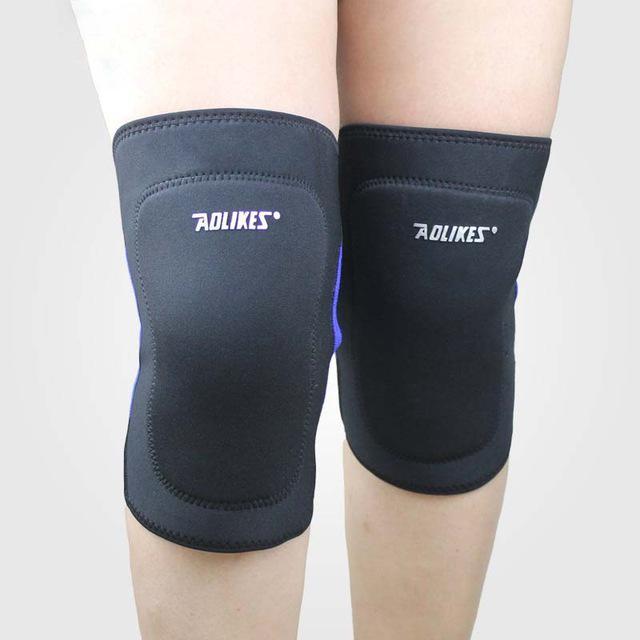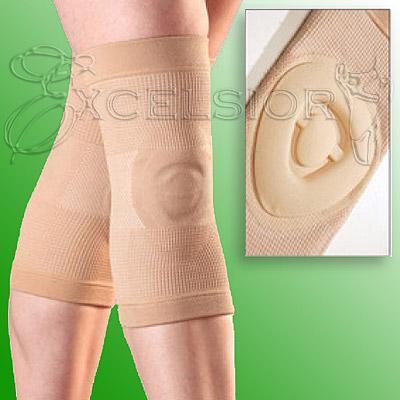The first image is the image on the left, the second image is the image on the right. Analyze the images presented: Is the assertion "There is at least one unworn knee pad to the right of a model's legs." valid? Answer yes or no. Yes. The first image is the image on the left, the second image is the image on the right. For the images displayed, is the sentence "Each image contains a pair of legs with the leg on the left bent and overlapping the right leg, and each image includes at least one hot pink knee pad." factually correct? Answer yes or no. No. 